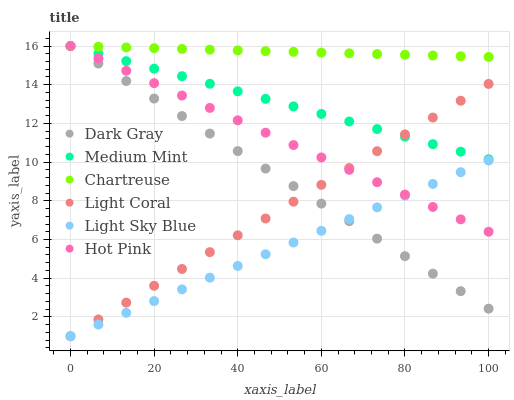Does Light Sky Blue have the minimum area under the curve?
Answer yes or no. Yes. Does Chartreuse have the maximum area under the curve?
Answer yes or no. Yes. Does Light Coral have the minimum area under the curve?
Answer yes or no. No. Does Light Coral have the maximum area under the curve?
Answer yes or no. No. Is Medium Mint the smoothest?
Answer yes or no. Yes. Is Chartreuse the roughest?
Answer yes or no. Yes. Is Light Coral the smoothest?
Answer yes or no. No. Is Light Coral the roughest?
Answer yes or no. No. Does Light Coral have the lowest value?
Answer yes or no. Yes. Does Hot Pink have the lowest value?
Answer yes or no. No. Does Chartreuse have the highest value?
Answer yes or no. Yes. Does Light Coral have the highest value?
Answer yes or no. No. Is Light Coral less than Chartreuse?
Answer yes or no. Yes. Is Medium Mint greater than Light Sky Blue?
Answer yes or no. Yes. Does Light Coral intersect Hot Pink?
Answer yes or no. Yes. Is Light Coral less than Hot Pink?
Answer yes or no. No. Is Light Coral greater than Hot Pink?
Answer yes or no. No. Does Light Coral intersect Chartreuse?
Answer yes or no. No. 